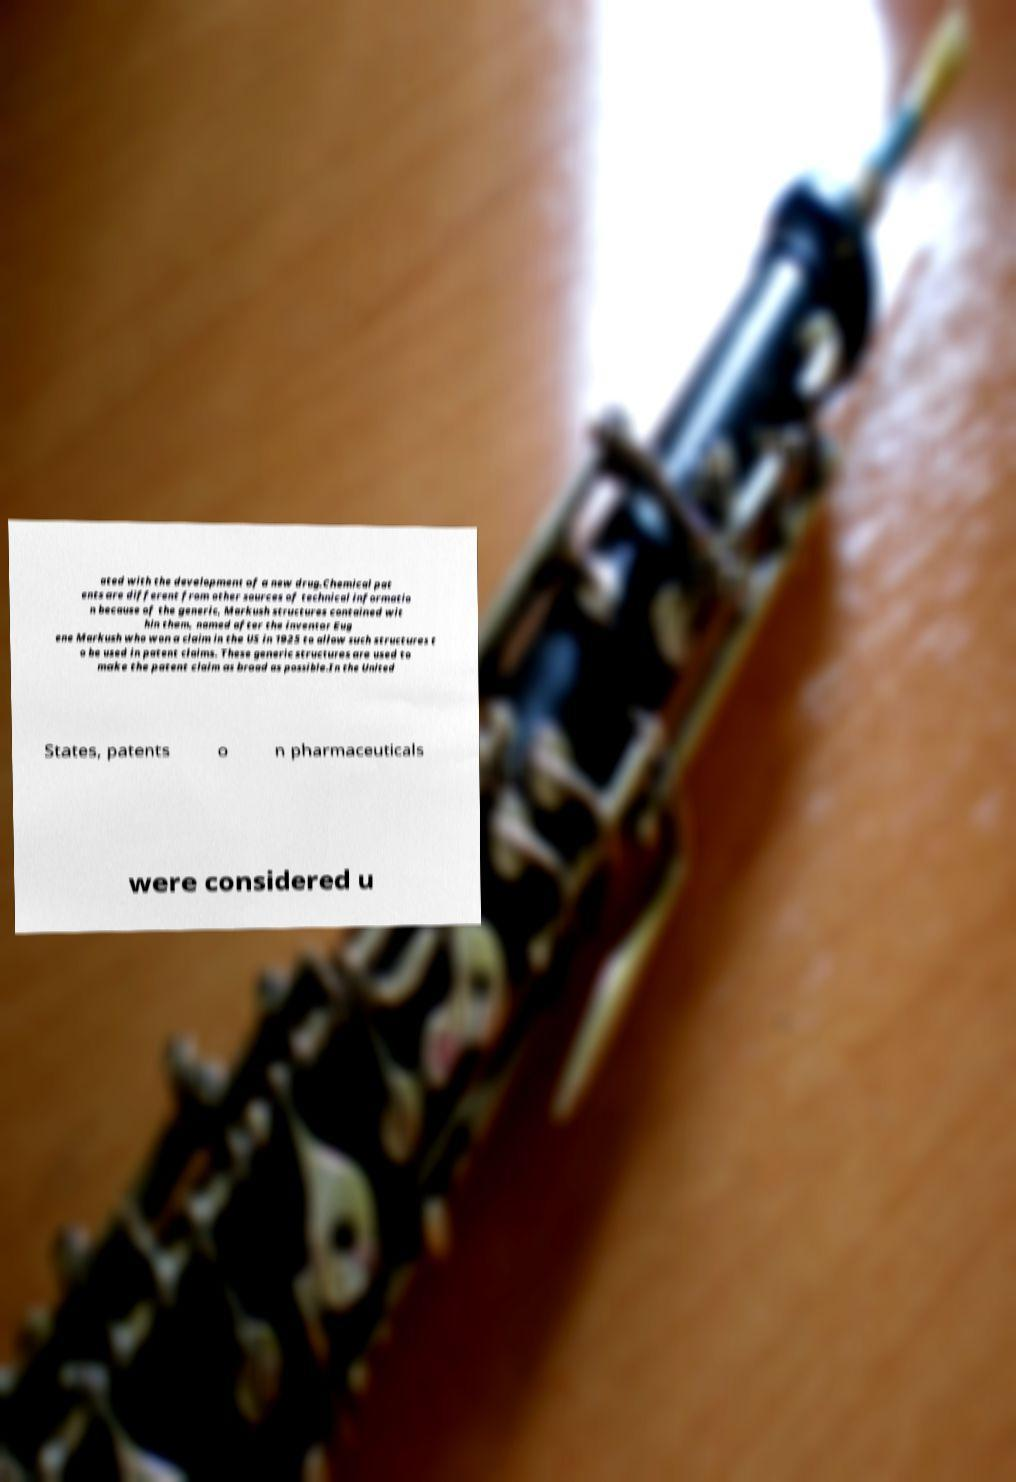Could you extract and type out the text from this image? ated with the development of a new drug.Chemical pat ents are different from other sources of technical informatio n because of the generic, Markush structures contained wit hin them, named after the inventor Eug ene Markush who won a claim in the US in 1925 to allow such structures t o be used in patent claims. These generic structures are used to make the patent claim as broad as possible.In the United States, patents o n pharmaceuticals were considered u 